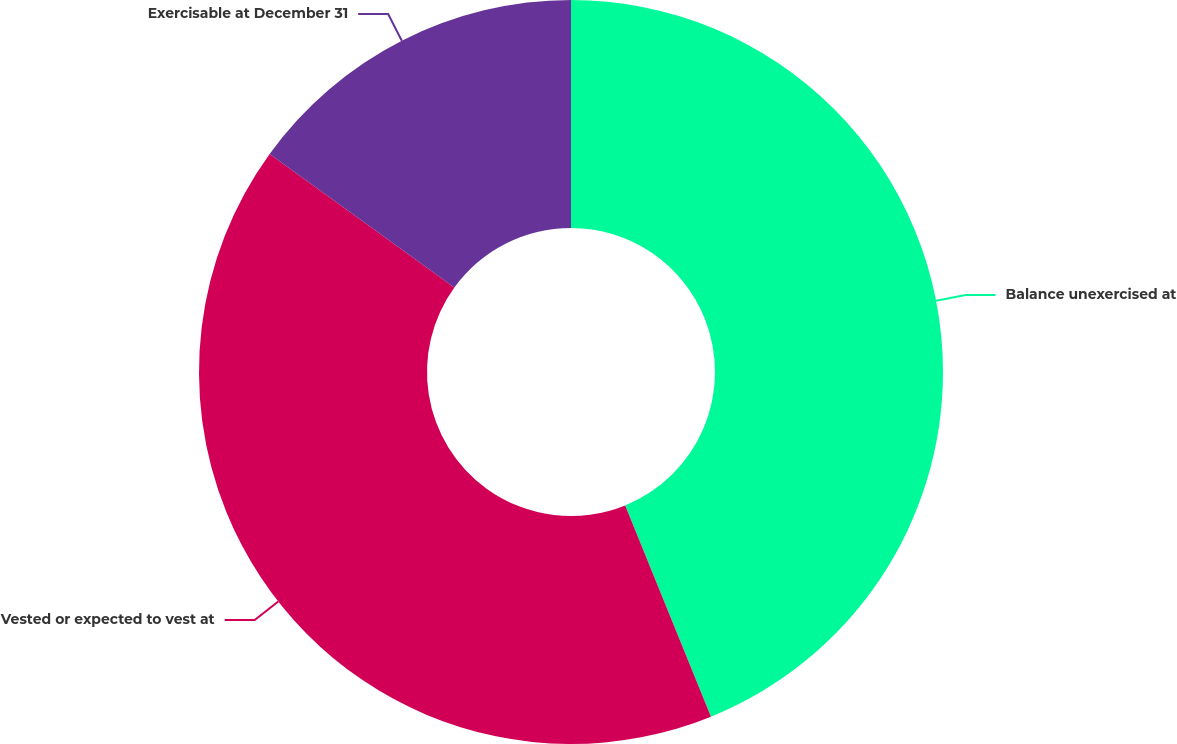Convert chart. <chart><loc_0><loc_0><loc_500><loc_500><pie_chart><fcel>Balance unexercised at<fcel>Vested or expected to vest at<fcel>Exercisable at December 31<nl><fcel>43.86%<fcel>41.11%<fcel>15.03%<nl></chart> 